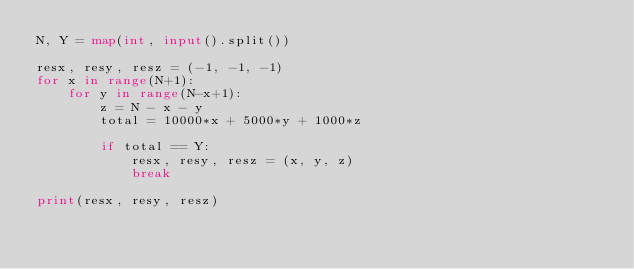<code> <loc_0><loc_0><loc_500><loc_500><_Python_>N, Y = map(int, input().split())

resx, resy, resz = (-1, -1, -1)
for x in range(N+1):
    for y in range(N-x+1):
        z = N - x - y
        total = 10000*x + 5000*y + 1000*z

        if total == Y:
            resx, resy, resz = (x, y, z)
            break

print(resx, resy, resz)</code> 